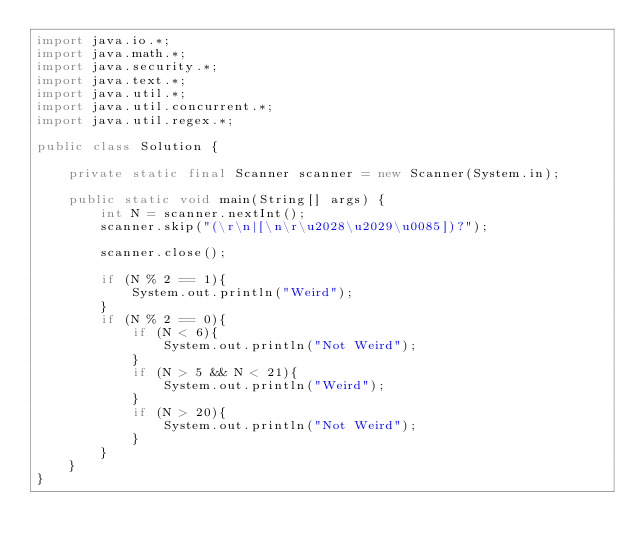Convert code to text. <code><loc_0><loc_0><loc_500><loc_500><_Java_>import java.io.*;
import java.math.*;
import java.security.*;
import java.text.*;
import java.util.*;
import java.util.concurrent.*;
import java.util.regex.*;

public class Solution {
    
    private static final Scanner scanner = new Scanner(System.in);

    public static void main(String[] args) {
        int N = scanner.nextInt();
        scanner.skip("(\r\n|[\n\r\u2028\u2029\u0085])?");

        scanner.close();
    
        if (N % 2 == 1){
            System.out.println("Weird");
        }
        if (N % 2 == 0){
            if (N < 6){
                System.out.println("Not Weird");
            }
            if (N > 5 && N < 21){
                System.out.println("Weird");
            }
            if (N > 20){
                System.out.println("Not Weird");
            }
        }
    }
}
</code> 